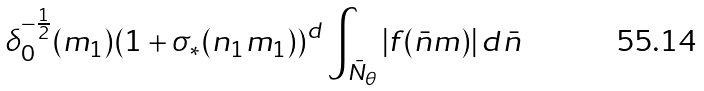Convert formula to latex. <formula><loc_0><loc_0><loc_500><loc_500>\delta ^ { - \frac { 1 } { 2 } } _ { 0 } ( m _ { 1 } ) ( 1 + \sigma _ { * } ( n _ { 1 } m _ { 1 } ) ) ^ { d } \int _ { \bar { N } _ { \theta } } | f ( \bar { n } m ) | \, d \bar { n }</formula> 